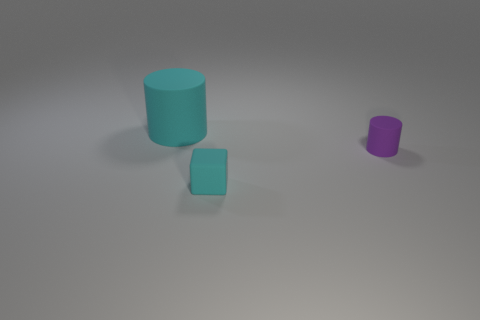There is a matte thing behind the rubber cylinder in front of the cyan matte cylinder; are there any large cyan rubber cylinders right of it?
Provide a short and direct response. No. How many small objects are rubber cubes or matte cylinders?
Your answer should be compact. 2. Is there anything else of the same color as the tiny cube?
Your response must be concise. Yes. Does the rubber cylinder that is to the right of the cyan cylinder have the same size as the cyan block?
Keep it short and to the point. Yes. There is a cylinder in front of the cyan object to the left of the small matte thing to the left of the tiny cylinder; what color is it?
Provide a short and direct response. Purple. What is the color of the matte block?
Give a very brief answer. Cyan. Is the color of the small rubber block the same as the large matte object?
Your answer should be compact. Yes. Is the material of the cyan object on the right side of the big matte cylinder the same as the cyan thing behind the small purple cylinder?
Provide a short and direct response. Yes. What is the material of the small thing that is the same shape as the large thing?
Give a very brief answer. Rubber. Do the purple cylinder and the cyan cube have the same material?
Your answer should be very brief. Yes. 